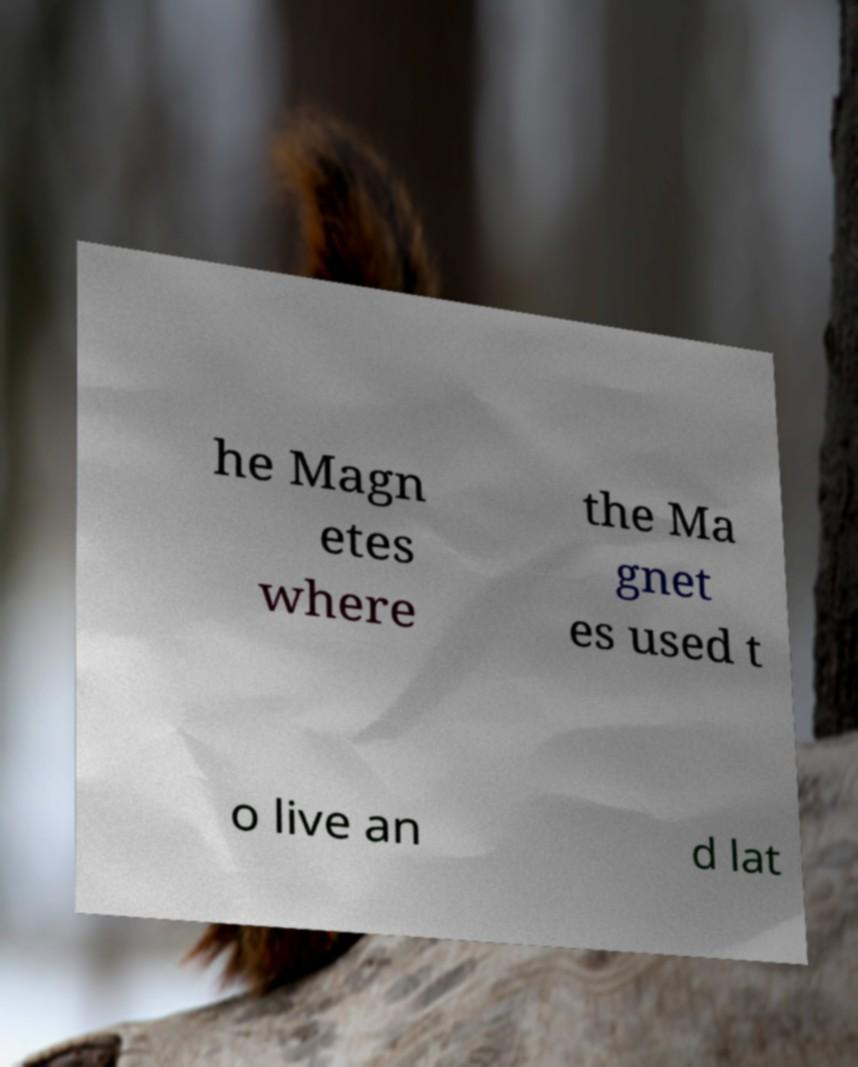Can you accurately transcribe the text from the provided image for me? he Magn etes where the Ma gnet es used t o live an d lat 